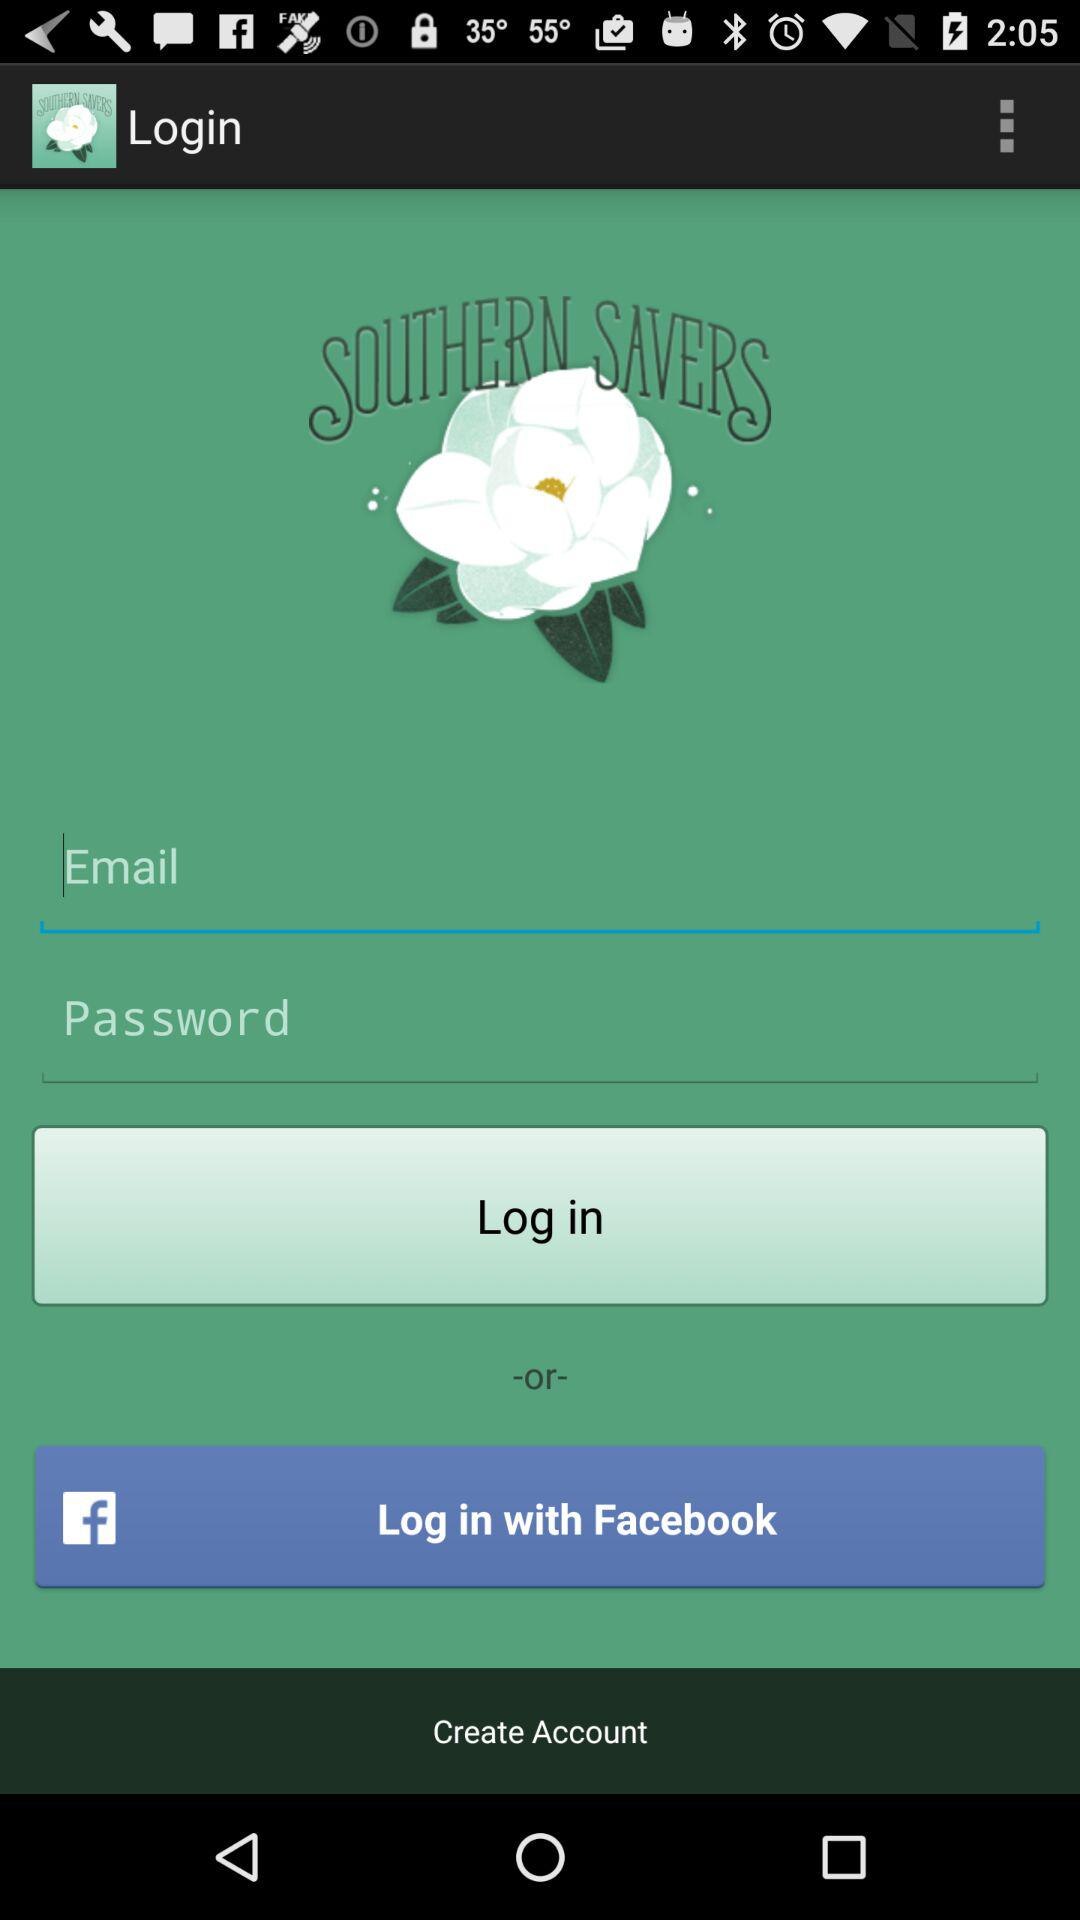How can we login? You can login through "Email" and "Facebook". 